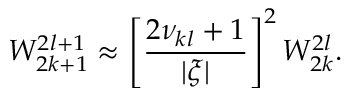<formula> <loc_0><loc_0><loc_500><loc_500>W _ { 2 k + 1 } ^ { 2 l + 1 } \approx \left [ \frac { 2 \nu _ { k l } + 1 } { | \xi | } \right ] ^ { 2 } W _ { 2 k } ^ { 2 l } .</formula> 